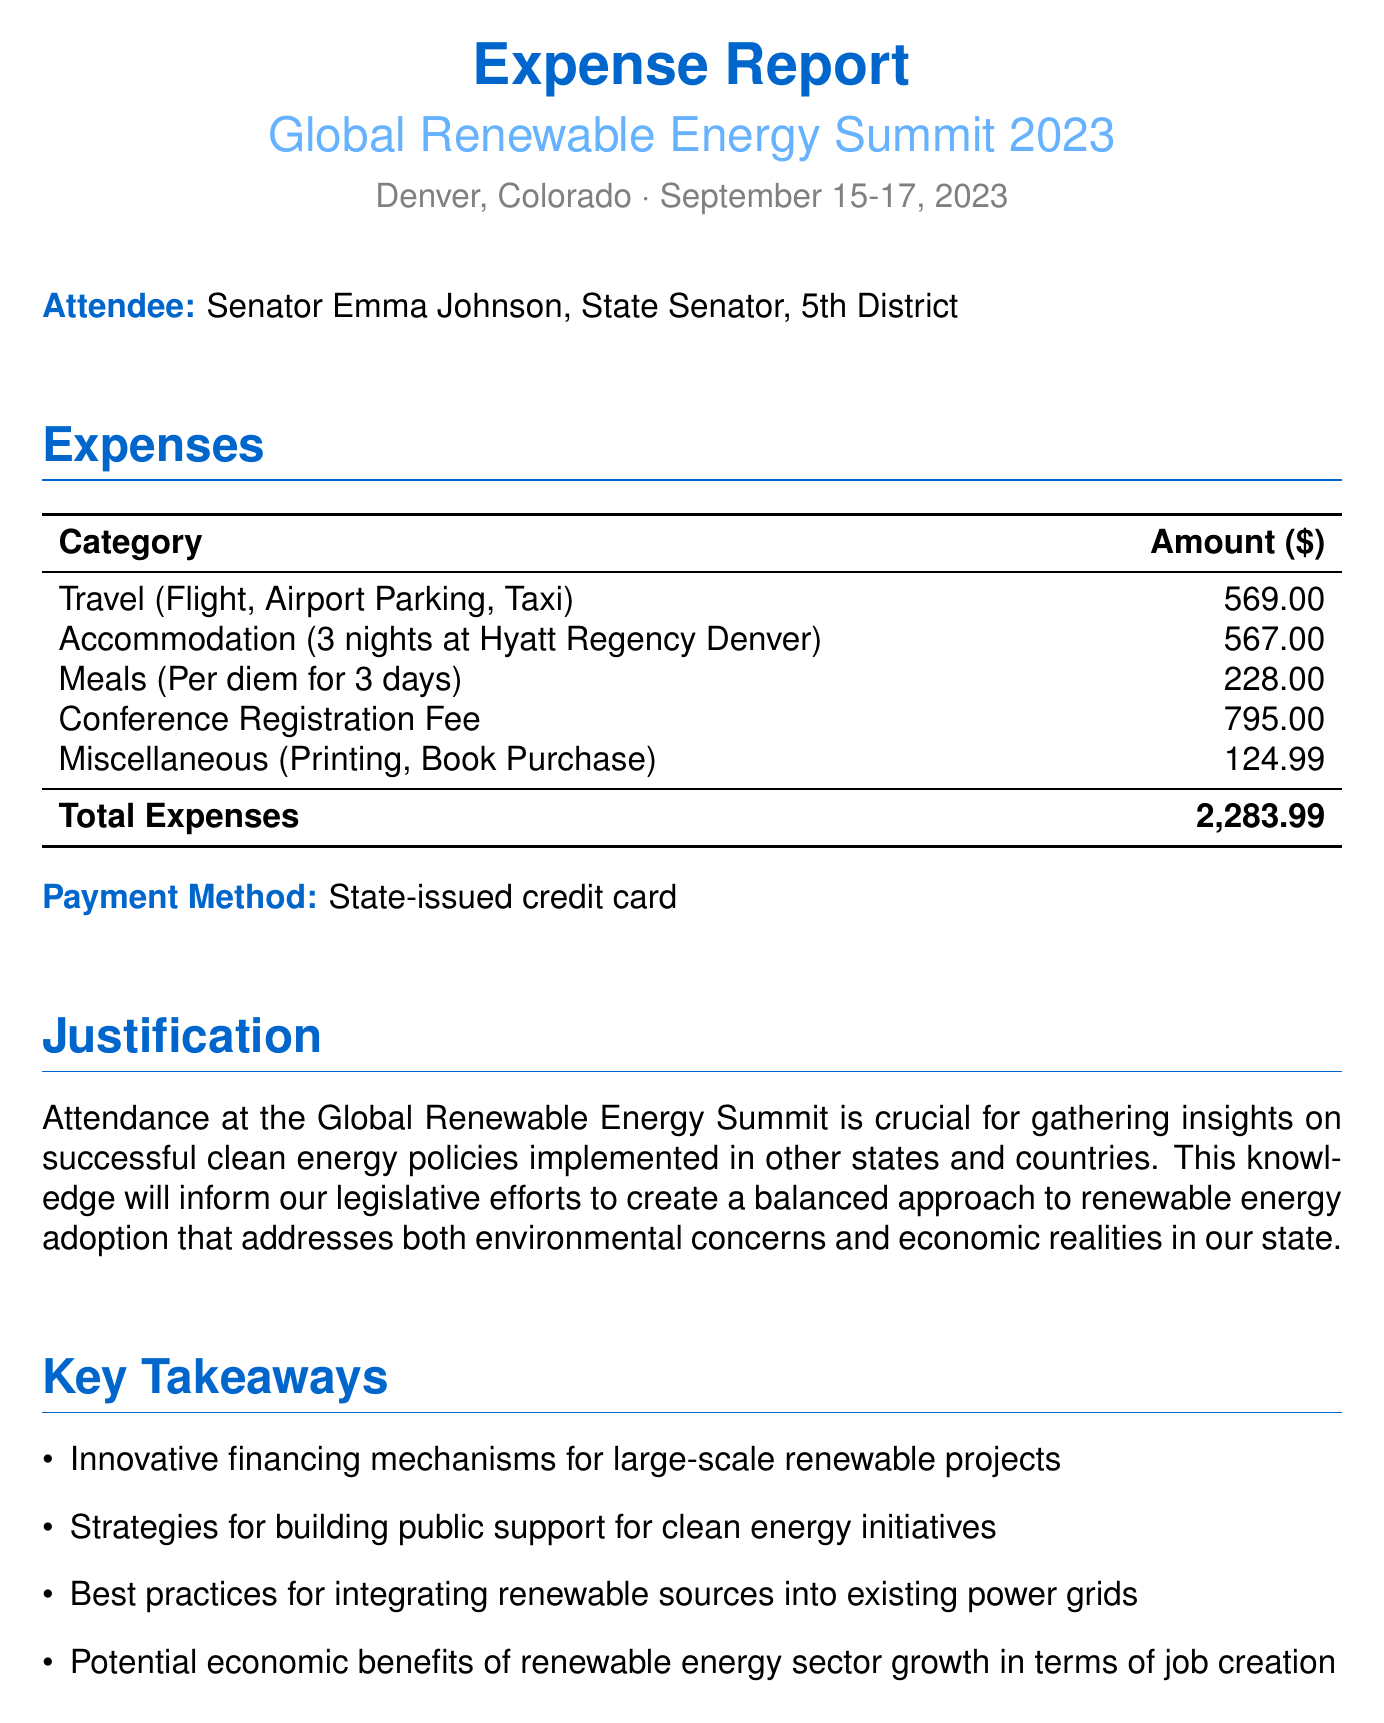What is the name of the conference? The document specifies the name of the conference attended, which is the "Global Renewable Energy Summit 2023."
Answer: Global Renewable Energy Summit 2023 What were the conference dates? The document outlines the dates of the conference as September 15-17, 2023.
Answer: September 15-17, 2023 How much was spent on accommodation? The document provides the total cost for accommodation, which is $567.00 for the hotel stay.
Answer: $567.00 Who is the attendee? The document names the attendee as Senator Emma Johnson, representing the 5th District.
Answer: Senator Emma Johnson What is the total expense amount? The total expenses are calculated and reported in the document as $2,283.99.
Answer: $2,283.99 What type of payment method was used? The document states that a state-issued credit card was the method of payment for the expenses.
Answer: State-issued credit card What was a key takeaway related to public support? The document lists one key takeaway as strategies for building public support for clean energy initiatives.
Answer: Strategies for building public support for clean energy initiatives What was the justification for attending the conference? The document explains that attendance is crucial for gathering insights on clean energy policies to inform legislative efforts.
Answer: Gathering insights on successful clean energy policies How many nights did the attendee stay at the hotel? The document indicates that the hotel stay was for a total of 3 nights.
Answer: 3 nights 